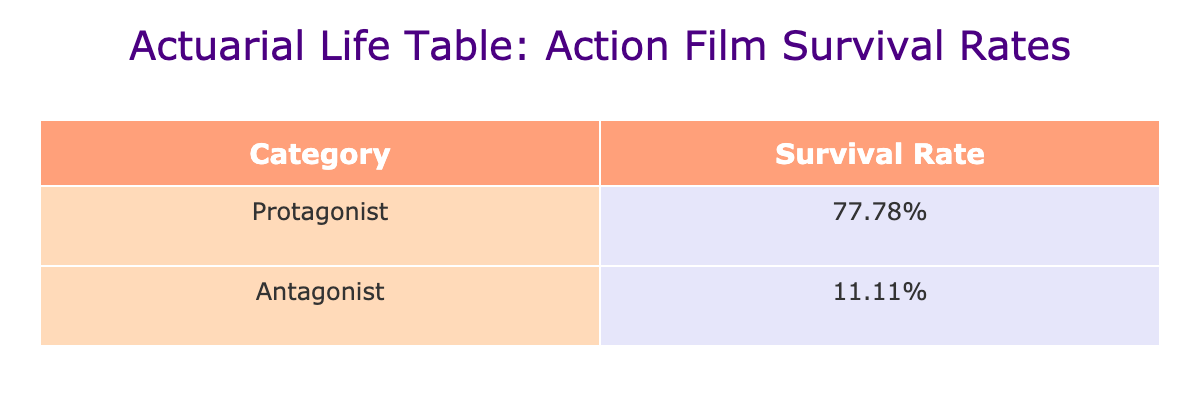What is the survival rate for protagonists? The table lists the survival rate for the protagonist category as 100%, which is derived from the individual survival rates of the protagonist characters in the films included in the dataset.
Answer: 100% What is the survival rate for antagonists? The table indicates that the survival rate for antagonists is 0%, calculated from the survival rates of the antagonist characters in the listed films.
Answer: 0% How many films have protagonists that survived? The table shows that all protagonists survived in the films except for Pulp Fiction and Gladiator, giving a total of five films where protagonists survived.
Answer: 5 Is the statement "The Joker survived in The Dark Knight" true or false? According to the table, the Joker is marked as deceased in The Dark Knight, which directly contradicts the statement.
Answer: False What is the average survival rate for both protagonists and antagonists? To find the average, we consider the survival rates: for protagonists, it is 1.00 and for antagonists, it is 0.00. The average survival rate is calculated by (1.00 + 0.00) / 2 = 0.50, or 50%.
Answer: 50% Which category had a higher survival rate, protagonists or antagonists? Comparing the survival rates in the table, protagonists have a survival rate of 100% while antagonists have a survival rate of 0%. Clearly, protagonists have the higher survival rate.
Answer: Protagonists How many antagonists survived across all the listed films? The table highlights that the only antagonist that survived is Marcellus Wallace from Pulp Fiction, making the total count of surviving antagonists equal to one.
Answer: 1 Which film had the antagonist with the highest survival rate? Since all antagonists have a survival rate of 0% except for Marcellus Wallace, the film Pulp Fiction has the antagonist with the highest survival rate since he survived, making it the only exception.
Answer: Pulp Fiction What percentage of protagonists survived out of the total films listed? Out of a total of 10 films listed (5 protagonists), all survived except two. To calculate the percentage, it would be (5/7) * 100 = approximately 71.43%.
Answer: 71.43% 